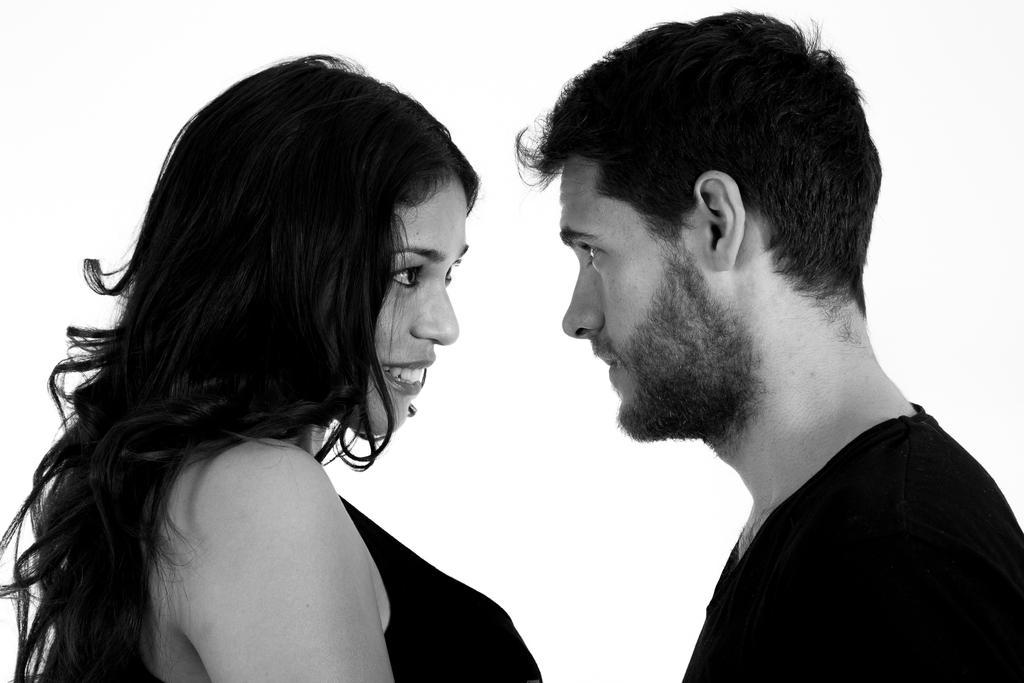In one or two sentences, can you explain what this image depicts? In this picture we can see a woman smiling and a man and they are looking at each other and in the background it is white color. 